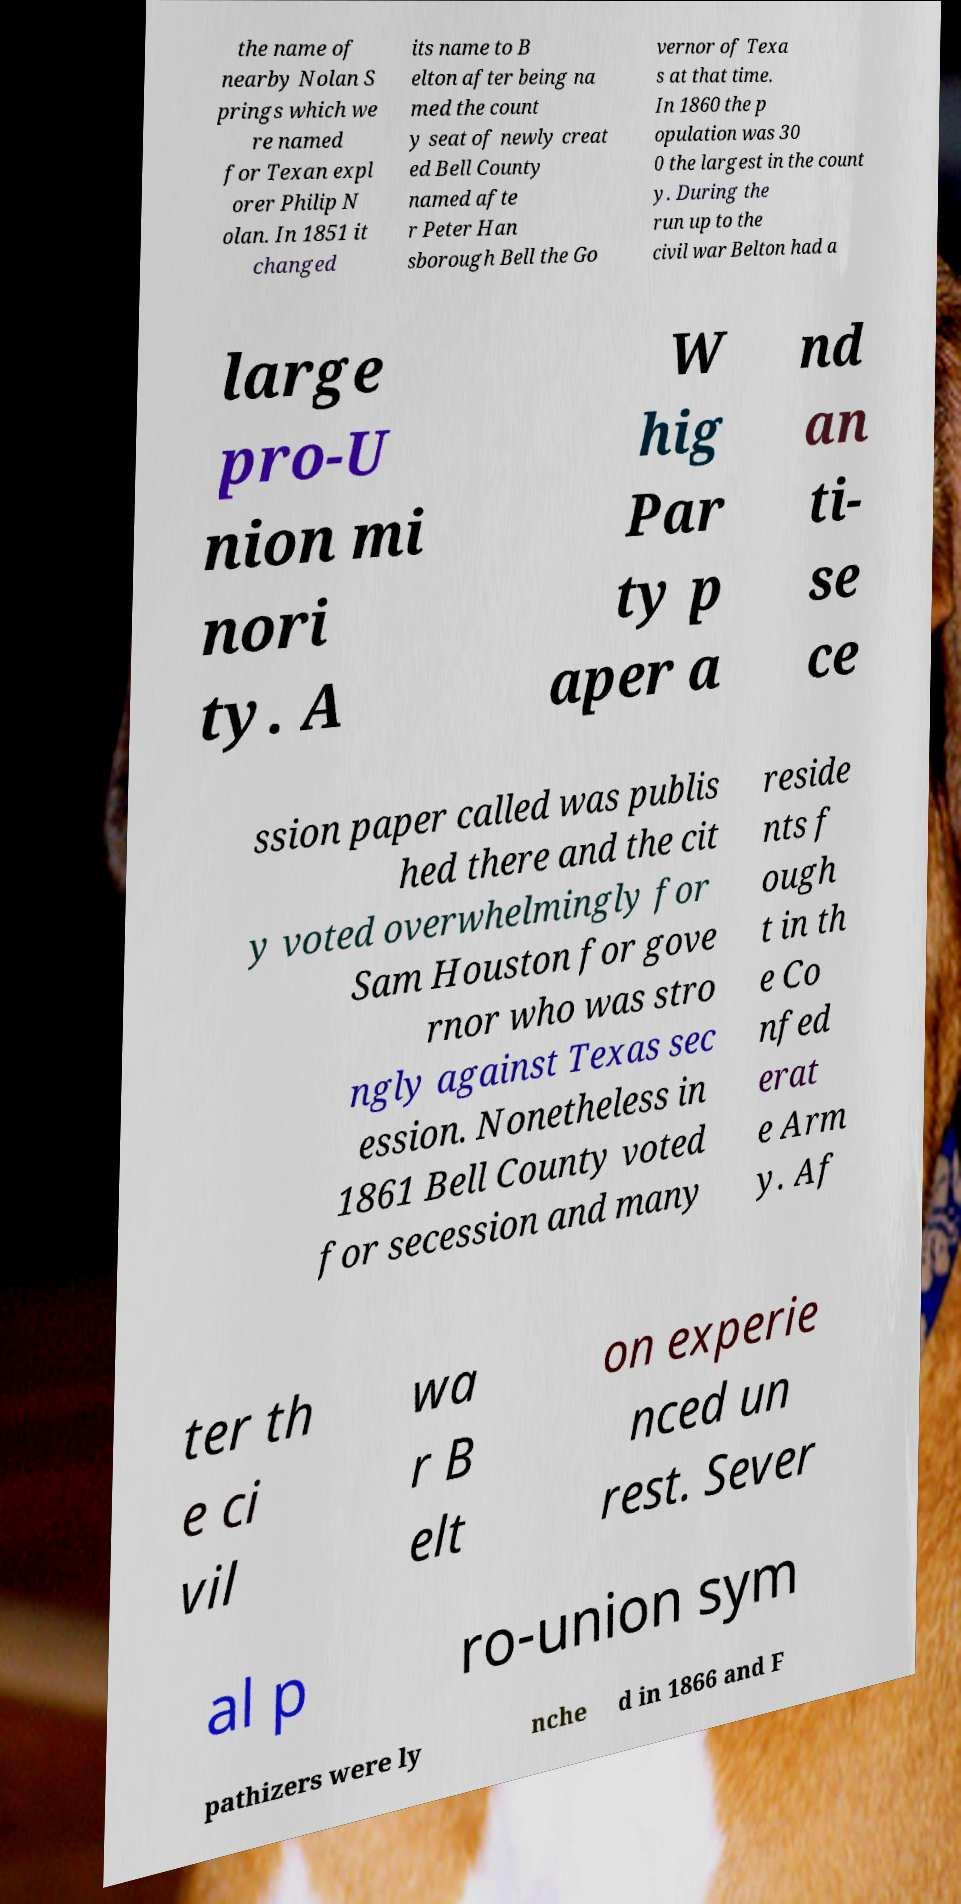I need the written content from this picture converted into text. Can you do that? the name of nearby Nolan S prings which we re named for Texan expl orer Philip N olan. In 1851 it changed its name to B elton after being na med the count y seat of newly creat ed Bell County named afte r Peter Han sborough Bell the Go vernor of Texa s at that time. In 1860 the p opulation was 30 0 the largest in the count y. During the run up to the civil war Belton had a large pro-U nion mi nori ty. A W hig Par ty p aper a nd an ti- se ce ssion paper called was publis hed there and the cit y voted overwhelmingly for Sam Houston for gove rnor who was stro ngly against Texas sec ession. Nonetheless in 1861 Bell County voted for secession and many reside nts f ough t in th e Co nfed erat e Arm y. Af ter th e ci vil wa r B elt on experie nced un rest. Sever al p ro-union sym pathizers were ly nche d in 1866 and F 